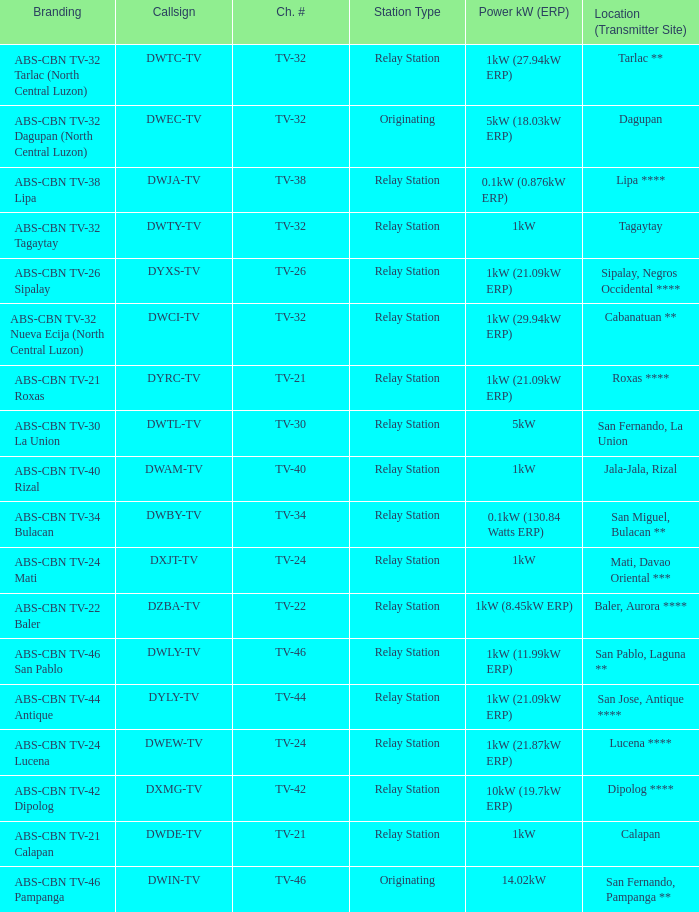The callsign DWEC-TV has what branding?  ABS-CBN TV-32 Dagupan (North Central Luzon). Could you help me parse every detail presented in this table? {'header': ['Branding', 'Callsign', 'Ch. #', 'Station Type', 'Power kW (ERP)', 'Location (Transmitter Site)'], 'rows': [['ABS-CBN TV-32 Tarlac (North Central Luzon)', 'DWTC-TV', 'TV-32', 'Relay Station', '1kW (27.94kW ERP)', 'Tarlac **'], ['ABS-CBN TV-32 Dagupan (North Central Luzon)', 'DWEC-TV', 'TV-32', 'Originating', '5kW (18.03kW ERP)', 'Dagupan'], ['ABS-CBN TV-38 Lipa', 'DWJA-TV', 'TV-38', 'Relay Station', '0.1kW (0.876kW ERP)', 'Lipa ****'], ['ABS-CBN TV-32 Tagaytay', 'DWTY-TV', 'TV-32', 'Relay Station', '1kW', 'Tagaytay'], ['ABS-CBN TV-26 Sipalay', 'DYXS-TV', 'TV-26', 'Relay Station', '1kW (21.09kW ERP)', 'Sipalay, Negros Occidental ****'], ['ABS-CBN TV-32 Nueva Ecija (North Central Luzon)', 'DWCI-TV', 'TV-32', 'Relay Station', '1kW (29.94kW ERP)', 'Cabanatuan **'], ['ABS-CBN TV-21 Roxas', 'DYRC-TV', 'TV-21', 'Relay Station', '1kW (21.09kW ERP)', 'Roxas ****'], ['ABS-CBN TV-30 La Union', 'DWTL-TV', 'TV-30', 'Relay Station', '5kW', 'San Fernando, La Union'], ['ABS-CBN TV-40 Rizal', 'DWAM-TV', 'TV-40', 'Relay Station', '1kW', 'Jala-Jala, Rizal'], ['ABS-CBN TV-34 Bulacan', 'DWBY-TV', 'TV-34', 'Relay Station', '0.1kW (130.84 Watts ERP)', 'San Miguel, Bulacan **'], ['ABS-CBN TV-24 Mati', 'DXJT-TV', 'TV-24', 'Relay Station', '1kW', 'Mati, Davao Oriental ***'], ['ABS-CBN TV-22 Baler', 'DZBA-TV', 'TV-22', 'Relay Station', '1kW (8.45kW ERP)', 'Baler, Aurora ****'], ['ABS-CBN TV-46 San Pablo', 'DWLY-TV', 'TV-46', 'Relay Station', '1kW (11.99kW ERP)', 'San Pablo, Laguna **'], ['ABS-CBN TV-44 Antique', 'DYLY-TV', 'TV-44', 'Relay Station', '1kW (21.09kW ERP)', 'San Jose, Antique ****'], ['ABS-CBN TV-24 Lucena', 'DWEW-TV', 'TV-24', 'Relay Station', '1kW (21.87kW ERP)', 'Lucena ****'], ['ABS-CBN TV-42 Dipolog', 'DXMG-TV', 'TV-42', 'Relay Station', '10kW (19.7kW ERP)', 'Dipolog ****'], ['ABS-CBN TV-21 Calapan', 'DWDE-TV', 'TV-21', 'Relay Station', '1kW', 'Calapan'], ['ABS-CBN TV-46 Pampanga', 'DWIN-TV', 'TV-46', 'Originating', '14.02kW', 'San Fernando, Pampanga **']]} 